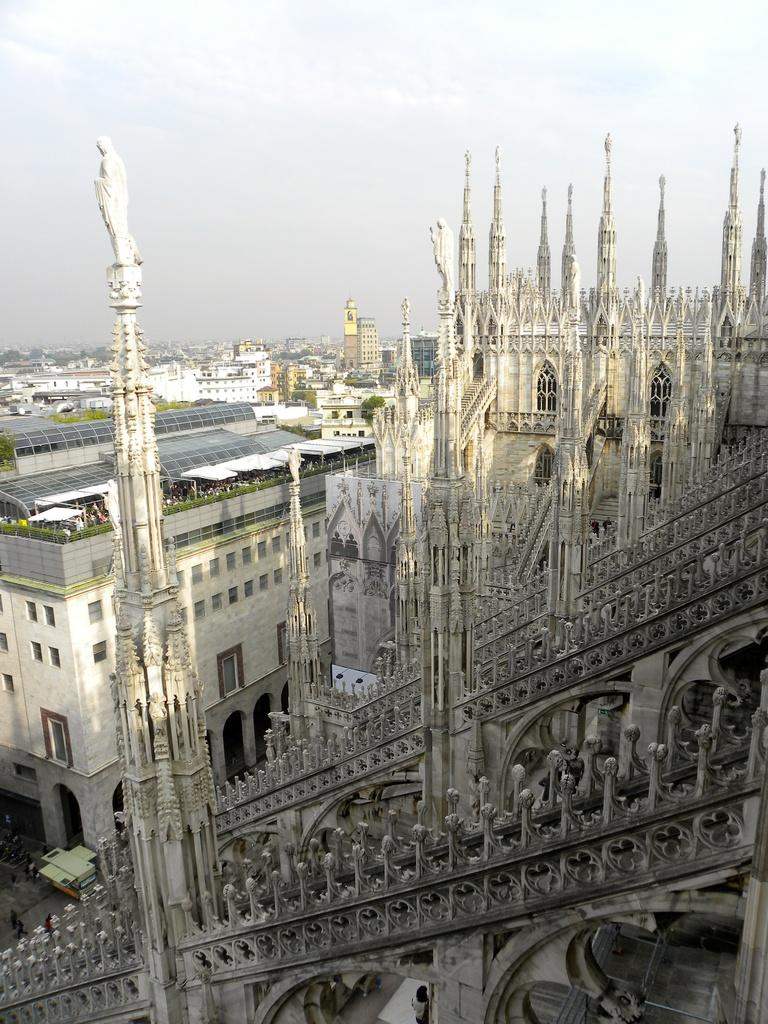What structures are present in the image? There are buildings in the image. What can be seen in the background of the image? The sky is visible in the background of the image. How many babies are sitting on the giraffe in the image? There are no babies or giraffes present in the image. 